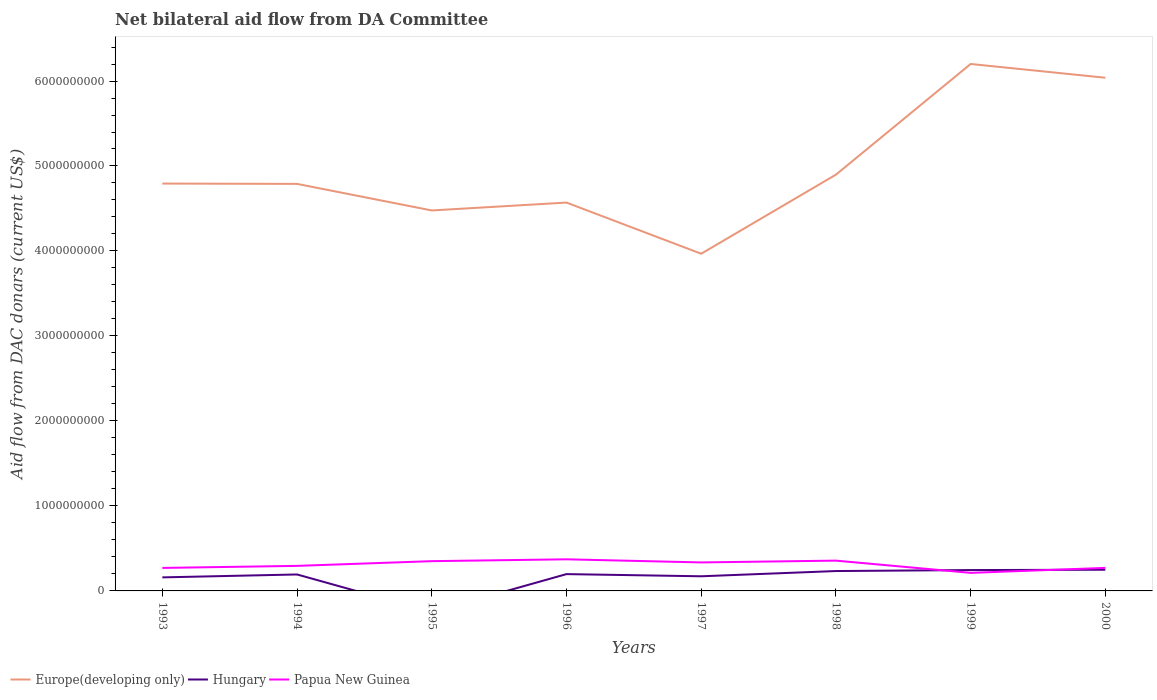How many different coloured lines are there?
Offer a very short reply. 3. Does the line corresponding to Europe(developing only) intersect with the line corresponding to Papua New Guinea?
Your answer should be very brief. No. Across all years, what is the maximum aid flow in in Papua New Guinea?
Give a very brief answer. 2.12e+08. What is the total aid flow in in Papua New Guinea in the graph?
Your answer should be compact. 1.23e+08. What is the difference between the highest and the second highest aid flow in in Hungary?
Your answer should be very brief. 2.49e+08. What is the difference between two consecutive major ticks on the Y-axis?
Give a very brief answer. 1.00e+09. Does the graph contain grids?
Give a very brief answer. No. Where does the legend appear in the graph?
Keep it short and to the point. Bottom left. How many legend labels are there?
Offer a terse response. 3. What is the title of the graph?
Ensure brevity in your answer.  Net bilateral aid flow from DA Committee. Does "Uzbekistan" appear as one of the legend labels in the graph?
Provide a short and direct response. No. What is the label or title of the X-axis?
Keep it short and to the point. Years. What is the label or title of the Y-axis?
Offer a very short reply. Aid flow from DAC donars (current US$). What is the Aid flow from DAC donars (current US$) of Europe(developing only) in 1993?
Ensure brevity in your answer.  4.79e+09. What is the Aid flow from DAC donars (current US$) in Hungary in 1993?
Make the answer very short. 1.59e+08. What is the Aid flow from DAC donars (current US$) in Papua New Guinea in 1993?
Your answer should be compact. 2.71e+08. What is the Aid flow from DAC donars (current US$) in Europe(developing only) in 1994?
Offer a terse response. 4.79e+09. What is the Aid flow from DAC donars (current US$) in Hungary in 1994?
Ensure brevity in your answer.  1.94e+08. What is the Aid flow from DAC donars (current US$) in Papua New Guinea in 1994?
Your answer should be very brief. 2.95e+08. What is the Aid flow from DAC donars (current US$) in Europe(developing only) in 1995?
Ensure brevity in your answer.  4.48e+09. What is the Aid flow from DAC donars (current US$) of Hungary in 1995?
Give a very brief answer. 0. What is the Aid flow from DAC donars (current US$) in Papua New Guinea in 1995?
Your answer should be compact. 3.50e+08. What is the Aid flow from DAC donars (current US$) in Europe(developing only) in 1996?
Your answer should be compact. 4.57e+09. What is the Aid flow from DAC donars (current US$) of Hungary in 1996?
Your answer should be very brief. 1.98e+08. What is the Aid flow from DAC donars (current US$) in Papua New Guinea in 1996?
Make the answer very short. 3.72e+08. What is the Aid flow from DAC donars (current US$) in Europe(developing only) in 1997?
Your answer should be very brief. 3.97e+09. What is the Aid flow from DAC donars (current US$) in Hungary in 1997?
Offer a very short reply. 1.72e+08. What is the Aid flow from DAC donars (current US$) of Papua New Guinea in 1997?
Keep it short and to the point. 3.35e+08. What is the Aid flow from DAC donars (current US$) in Europe(developing only) in 1998?
Your answer should be very brief. 4.90e+09. What is the Aid flow from DAC donars (current US$) in Hungary in 1998?
Provide a short and direct response. 2.34e+08. What is the Aid flow from DAC donars (current US$) in Papua New Guinea in 1998?
Your response must be concise. 3.56e+08. What is the Aid flow from DAC donars (current US$) in Europe(developing only) in 1999?
Offer a terse response. 6.20e+09. What is the Aid flow from DAC donars (current US$) of Hungary in 1999?
Your answer should be very brief. 2.45e+08. What is the Aid flow from DAC donars (current US$) of Papua New Guinea in 1999?
Your response must be concise. 2.12e+08. What is the Aid flow from DAC donars (current US$) of Europe(developing only) in 2000?
Your answer should be very brief. 6.04e+09. What is the Aid flow from DAC donars (current US$) in Hungary in 2000?
Give a very brief answer. 2.49e+08. What is the Aid flow from DAC donars (current US$) in Papua New Guinea in 2000?
Make the answer very short. 2.71e+08. Across all years, what is the maximum Aid flow from DAC donars (current US$) in Europe(developing only)?
Offer a very short reply. 6.20e+09. Across all years, what is the maximum Aid flow from DAC donars (current US$) in Hungary?
Your response must be concise. 2.49e+08. Across all years, what is the maximum Aid flow from DAC donars (current US$) in Papua New Guinea?
Offer a terse response. 3.72e+08. Across all years, what is the minimum Aid flow from DAC donars (current US$) in Europe(developing only)?
Ensure brevity in your answer.  3.97e+09. Across all years, what is the minimum Aid flow from DAC donars (current US$) of Papua New Guinea?
Offer a very short reply. 2.12e+08. What is the total Aid flow from DAC donars (current US$) of Europe(developing only) in the graph?
Provide a succinct answer. 3.97e+1. What is the total Aid flow from DAC donars (current US$) of Hungary in the graph?
Ensure brevity in your answer.  1.45e+09. What is the total Aid flow from DAC donars (current US$) in Papua New Guinea in the graph?
Offer a very short reply. 2.46e+09. What is the difference between the Aid flow from DAC donars (current US$) of Europe(developing only) in 1993 and that in 1994?
Your answer should be compact. 3.82e+06. What is the difference between the Aid flow from DAC donars (current US$) in Hungary in 1993 and that in 1994?
Keep it short and to the point. -3.43e+07. What is the difference between the Aid flow from DAC donars (current US$) in Papua New Guinea in 1993 and that in 1994?
Your response must be concise. -2.41e+07. What is the difference between the Aid flow from DAC donars (current US$) in Europe(developing only) in 1993 and that in 1995?
Ensure brevity in your answer.  3.16e+08. What is the difference between the Aid flow from DAC donars (current US$) of Papua New Guinea in 1993 and that in 1995?
Your response must be concise. -7.95e+07. What is the difference between the Aid flow from DAC donars (current US$) in Europe(developing only) in 1993 and that in 1996?
Provide a short and direct response. 2.24e+08. What is the difference between the Aid flow from DAC donars (current US$) in Hungary in 1993 and that in 1996?
Offer a terse response. -3.85e+07. What is the difference between the Aid flow from DAC donars (current US$) of Papua New Guinea in 1993 and that in 1996?
Keep it short and to the point. -1.01e+08. What is the difference between the Aid flow from DAC donars (current US$) of Europe(developing only) in 1993 and that in 1997?
Give a very brief answer. 8.26e+08. What is the difference between the Aid flow from DAC donars (current US$) in Hungary in 1993 and that in 1997?
Offer a very short reply. -1.29e+07. What is the difference between the Aid flow from DAC donars (current US$) in Papua New Guinea in 1993 and that in 1997?
Ensure brevity in your answer.  -6.48e+07. What is the difference between the Aid flow from DAC donars (current US$) in Europe(developing only) in 1993 and that in 1998?
Your answer should be compact. -1.05e+08. What is the difference between the Aid flow from DAC donars (current US$) in Hungary in 1993 and that in 1998?
Your response must be concise. -7.45e+07. What is the difference between the Aid flow from DAC donars (current US$) of Papua New Guinea in 1993 and that in 1998?
Offer a terse response. -8.58e+07. What is the difference between the Aid flow from DAC donars (current US$) in Europe(developing only) in 1993 and that in 1999?
Your answer should be compact. -1.41e+09. What is the difference between the Aid flow from DAC donars (current US$) of Hungary in 1993 and that in 1999?
Provide a short and direct response. -8.61e+07. What is the difference between the Aid flow from DAC donars (current US$) in Papua New Guinea in 1993 and that in 1999?
Your answer should be compact. 5.82e+07. What is the difference between the Aid flow from DAC donars (current US$) of Europe(developing only) in 1993 and that in 2000?
Offer a very short reply. -1.25e+09. What is the difference between the Aid flow from DAC donars (current US$) in Hungary in 1993 and that in 2000?
Provide a short and direct response. -8.99e+07. What is the difference between the Aid flow from DAC donars (current US$) of Papua New Guinea in 1993 and that in 2000?
Your answer should be compact. -2.60e+05. What is the difference between the Aid flow from DAC donars (current US$) of Europe(developing only) in 1994 and that in 1995?
Your answer should be very brief. 3.13e+08. What is the difference between the Aid flow from DAC donars (current US$) of Papua New Guinea in 1994 and that in 1995?
Give a very brief answer. -5.54e+07. What is the difference between the Aid flow from DAC donars (current US$) in Europe(developing only) in 1994 and that in 1996?
Provide a succinct answer. 2.20e+08. What is the difference between the Aid flow from DAC donars (current US$) of Hungary in 1994 and that in 1996?
Your answer should be compact. -4.16e+06. What is the difference between the Aid flow from DAC donars (current US$) in Papua New Guinea in 1994 and that in 1996?
Your answer should be compact. -7.72e+07. What is the difference between the Aid flow from DAC donars (current US$) of Europe(developing only) in 1994 and that in 1997?
Your answer should be very brief. 8.22e+08. What is the difference between the Aid flow from DAC donars (current US$) of Hungary in 1994 and that in 1997?
Give a very brief answer. 2.14e+07. What is the difference between the Aid flow from DAC donars (current US$) in Papua New Guinea in 1994 and that in 1997?
Ensure brevity in your answer.  -4.06e+07. What is the difference between the Aid flow from DAC donars (current US$) of Europe(developing only) in 1994 and that in 1998?
Ensure brevity in your answer.  -1.09e+08. What is the difference between the Aid flow from DAC donars (current US$) in Hungary in 1994 and that in 1998?
Offer a terse response. -4.02e+07. What is the difference between the Aid flow from DAC donars (current US$) of Papua New Guinea in 1994 and that in 1998?
Offer a very short reply. -6.17e+07. What is the difference between the Aid flow from DAC donars (current US$) in Europe(developing only) in 1994 and that in 1999?
Keep it short and to the point. -1.41e+09. What is the difference between the Aid flow from DAC donars (current US$) in Hungary in 1994 and that in 1999?
Your answer should be very brief. -5.18e+07. What is the difference between the Aid flow from DAC donars (current US$) in Papua New Guinea in 1994 and that in 1999?
Provide a succinct answer. 8.23e+07. What is the difference between the Aid flow from DAC donars (current US$) of Europe(developing only) in 1994 and that in 2000?
Make the answer very short. -1.25e+09. What is the difference between the Aid flow from DAC donars (current US$) of Hungary in 1994 and that in 2000?
Give a very brief answer. -5.56e+07. What is the difference between the Aid flow from DAC donars (current US$) of Papua New Guinea in 1994 and that in 2000?
Ensure brevity in your answer.  2.38e+07. What is the difference between the Aid flow from DAC donars (current US$) in Europe(developing only) in 1995 and that in 1996?
Keep it short and to the point. -9.28e+07. What is the difference between the Aid flow from DAC donars (current US$) of Papua New Guinea in 1995 and that in 1996?
Provide a short and direct response. -2.17e+07. What is the difference between the Aid flow from DAC donars (current US$) in Europe(developing only) in 1995 and that in 1997?
Your answer should be very brief. 5.09e+08. What is the difference between the Aid flow from DAC donars (current US$) of Papua New Guinea in 1995 and that in 1997?
Your response must be concise. 1.48e+07. What is the difference between the Aid flow from DAC donars (current US$) in Europe(developing only) in 1995 and that in 1998?
Give a very brief answer. -4.21e+08. What is the difference between the Aid flow from DAC donars (current US$) of Papua New Guinea in 1995 and that in 1998?
Make the answer very short. -6.30e+06. What is the difference between the Aid flow from DAC donars (current US$) of Europe(developing only) in 1995 and that in 1999?
Give a very brief answer. -1.72e+09. What is the difference between the Aid flow from DAC donars (current US$) in Papua New Guinea in 1995 and that in 1999?
Provide a short and direct response. 1.38e+08. What is the difference between the Aid flow from DAC donars (current US$) of Europe(developing only) in 1995 and that in 2000?
Keep it short and to the point. -1.56e+09. What is the difference between the Aid flow from DAC donars (current US$) of Papua New Guinea in 1995 and that in 2000?
Your answer should be compact. 7.92e+07. What is the difference between the Aid flow from DAC donars (current US$) in Europe(developing only) in 1996 and that in 1997?
Provide a short and direct response. 6.02e+08. What is the difference between the Aid flow from DAC donars (current US$) of Hungary in 1996 and that in 1997?
Keep it short and to the point. 2.56e+07. What is the difference between the Aid flow from DAC donars (current US$) in Papua New Guinea in 1996 and that in 1997?
Offer a terse response. 3.65e+07. What is the difference between the Aid flow from DAC donars (current US$) of Europe(developing only) in 1996 and that in 1998?
Offer a terse response. -3.28e+08. What is the difference between the Aid flow from DAC donars (current US$) of Hungary in 1996 and that in 1998?
Your answer should be compact. -3.61e+07. What is the difference between the Aid flow from DAC donars (current US$) of Papua New Guinea in 1996 and that in 1998?
Give a very brief answer. 1.54e+07. What is the difference between the Aid flow from DAC donars (current US$) of Europe(developing only) in 1996 and that in 1999?
Offer a terse response. -1.63e+09. What is the difference between the Aid flow from DAC donars (current US$) in Hungary in 1996 and that in 1999?
Offer a very short reply. -4.77e+07. What is the difference between the Aid flow from DAC donars (current US$) of Papua New Guinea in 1996 and that in 1999?
Give a very brief answer. 1.59e+08. What is the difference between the Aid flow from DAC donars (current US$) of Europe(developing only) in 1996 and that in 2000?
Your response must be concise. -1.47e+09. What is the difference between the Aid flow from DAC donars (current US$) of Hungary in 1996 and that in 2000?
Provide a short and direct response. -5.14e+07. What is the difference between the Aid flow from DAC donars (current US$) of Papua New Guinea in 1996 and that in 2000?
Your answer should be very brief. 1.01e+08. What is the difference between the Aid flow from DAC donars (current US$) of Europe(developing only) in 1997 and that in 1998?
Your answer should be very brief. -9.30e+08. What is the difference between the Aid flow from DAC donars (current US$) of Hungary in 1997 and that in 1998?
Make the answer very short. -6.17e+07. What is the difference between the Aid flow from DAC donars (current US$) of Papua New Guinea in 1997 and that in 1998?
Ensure brevity in your answer.  -2.11e+07. What is the difference between the Aid flow from DAC donars (current US$) of Europe(developing only) in 1997 and that in 1999?
Make the answer very short. -2.23e+09. What is the difference between the Aid flow from DAC donars (current US$) in Hungary in 1997 and that in 1999?
Make the answer very short. -7.33e+07. What is the difference between the Aid flow from DAC donars (current US$) in Papua New Guinea in 1997 and that in 1999?
Give a very brief answer. 1.23e+08. What is the difference between the Aid flow from DAC donars (current US$) of Europe(developing only) in 1997 and that in 2000?
Ensure brevity in your answer.  -2.07e+09. What is the difference between the Aid flow from DAC donars (current US$) of Hungary in 1997 and that in 2000?
Your answer should be compact. -7.70e+07. What is the difference between the Aid flow from DAC donars (current US$) in Papua New Guinea in 1997 and that in 2000?
Make the answer very short. 6.45e+07. What is the difference between the Aid flow from DAC donars (current US$) of Europe(developing only) in 1998 and that in 1999?
Your answer should be compact. -1.30e+09. What is the difference between the Aid flow from DAC donars (current US$) in Hungary in 1998 and that in 1999?
Offer a very short reply. -1.16e+07. What is the difference between the Aid flow from DAC donars (current US$) in Papua New Guinea in 1998 and that in 1999?
Provide a short and direct response. 1.44e+08. What is the difference between the Aid flow from DAC donars (current US$) in Europe(developing only) in 1998 and that in 2000?
Keep it short and to the point. -1.14e+09. What is the difference between the Aid flow from DAC donars (current US$) in Hungary in 1998 and that in 2000?
Offer a very short reply. -1.54e+07. What is the difference between the Aid flow from DAC donars (current US$) of Papua New Guinea in 1998 and that in 2000?
Provide a succinct answer. 8.56e+07. What is the difference between the Aid flow from DAC donars (current US$) of Europe(developing only) in 1999 and that in 2000?
Provide a succinct answer. 1.62e+08. What is the difference between the Aid flow from DAC donars (current US$) of Hungary in 1999 and that in 2000?
Your answer should be compact. -3.76e+06. What is the difference between the Aid flow from DAC donars (current US$) in Papua New Guinea in 1999 and that in 2000?
Give a very brief answer. -5.84e+07. What is the difference between the Aid flow from DAC donars (current US$) in Europe(developing only) in 1993 and the Aid flow from DAC donars (current US$) in Hungary in 1994?
Your answer should be very brief. 4.60e+09. What is the difference between the Aid flow from DAC donars (current US$) of Europe(developing only) in 1993 and the Aid flow from DAC donars (current US$) of Papua New Guinea in 1994?
Offer a very short reply. 4.50e+09. What is the difference between the Aid flow from DAC donars (current US$) of Hungary in 1993 and the Aid flow from DAC donars (current US$) of Papua New Guinea in 1994?
Provide a short and direct response. -1.35e+08. What is the difference between the Aid flow from DAC donars (current US$) in Europe(developing only) in 1993 and the Aid flow from DAC donars (current US$) in Papua New Guinea in 1995?
Your answer should be compact. 4.44e+09. What is the difference between the Aid flow from DAC donars (current US$) of Hungary in 1993 and the Aid flow from DAC donars (current US$) of Papua New Guinea in 1995?
Your answer should be compact. -1.91e+08. What is the difference between the Aid flow from DAC donars (current US$) of Europe(developing only) in 1993 and the Aid flow from DAC donars (current US$) of Hungary in 1996?
Give a very brief answer. 4.60e+09. What is the difference between the Aid flow from DAC donars (current US$) in Europe(developing only) in 1993 and the Aid flow from DAC donars (current US$) in Papua New Guinea in 1996?
Your response must be concise. 4.42e+09. What is the difference between the Aid flow from DAC donars (current US$) of Hungary in 1993 and the Aid flow from DAC donars (current US$) of Papua New Guinea in 1996?
Ensure brevity in your answer.  -2.13e+08. What is the difference between the Aid flow from DAC donars (current US$) of Europe(developing only) in 1993 and the Aid flow from DAC donars (current US$) of Hungary in 1997?
Your answer should be compact. 4.62e+09. What is the difference between the Aid flow from DAC donars (current US$) of Europe(developing only) in 1993 and the Aid flow from DAC donars (current US$) of Papua New Guinea in 1997?
Give a very brief answer. 4.46e+09. What is the difference between the Aid flow from DAC donars (current US$) in Hungary in 1993 and the Aid flow from DAC donars (current US$) in Papua New Guinea in 1997?
Your answer should be compact. -1.76e+08. What is the difference between the Aid flow from DAC donars (current US$) in Europe(developing only) in 1993 and the Aid flow from DAC donars (current US$) in Hungary in 1998?
Make the answer very short. 4.56e+09. What is the difference between the Aid flow from DAC donars (current US$) in Europe(developing only) in 1993 and the Aid flow from DAC donars (current US$) in Papua New Guinea in 1998?
Provide a succinct answer. 4.44e+09. What is the difference between the Aid flow from DAC donars (current US$) in Hungary in 1993 and the Aid flow from DAC donars (current US$) in Papua New Guinea in 1998?
Offer a very short reply. -1.97e+08. What is the difference between the Aid flow from DAC donars (current US$) of Europe(developing only) in 1993 and the Aid flow from DAC donars (current US$) of Hungary in 1999?
Your answer should be very brief. 4.55e+09. What is the difference between the Aid flow from DAC donars (current US$) of Europe(developing only) in 1993 and the Aid flow from DAC donars (current US$) of Papua New Guinea in 1999?
Give a very brief answer. 4.58e+09. What is the difference between the Aid flow from DAC donars (current US$) in Hungary in 1993 and the Aid flow from DAC donars (current US$) in Papua New Guinea in 1999?
Offer a terse response. -5.31e+07. What is the difference between the Aid flow from DAC donars (current US$) in Europe(developing only) in 1993 and the Aid flow from DAC donars (current US$) in Hungary in 2000?
Keep it short and to the point. 4.54e+09. What is the difference between the Aid flow from DAC donars (current US$) in Europe(developing only) in 1993 and the Aid flow from DAC donars (current US$) in Papua New Guinea in 2000?
Your answer should be very brief. 4.52e+09. What is the difference between the Aid flow from DAC donars (current US$) in Hungary in 1993 and the Aid flow from DAC donars (current US$) in Papua New Guinea in 2000?
Give a very brief answer. -1.12e+08. What is the difference between the Aid flow from DAC donars (current US$) of Europe(developing only) in 1994 and the Aid flow from DAC donars (current US$) of Papua New Guinea in 1995?
Ensure brevity in your answer.  4.44e+09. What is the difference between the Aid flow from DAC donars (current US$) in Hungary in 1994 and the Aid flow from DAC donars (current US$) in Papua New Guinea in 1995?
Offer a very short reply. -1.57e+08. What is the difference between the Aid flow from DAC donars (current US$) of Europe(developing only) in 1994 and the Aid flow from DAC donars (current US$) of Hungary in 1996?
Your response must be concise. 4.59e+09. What is the difference between the Aid flow from DAC donars (current US$) of Europe(developing only) in 1994 and the Aid flow from DAC donars (current US$) of Papua New Guinea in 1996?
Make the answer very short. 4.42e+09. What is the difference between the Aid flow from DAC donars (current US$) in Hungary in 1994 and the Aid flow from DAC donars (current US$) in Papua New Guinea in 1996?
Your answer should be compact. -1.78e+08. What is the difference between the Aid flow from DAC donars (current US$) of Europe(developing only) in 1994 and the Aid flow from DAC donars (current US$) of Hungary in 1997?
Ensure brevity in your answer.  4.62e+09. What is the difference between the Aid flow from DAC donars (current US$) in Europe(developing only) in 1994 and the Aid flow from DAC donars (current US$) in Papua New Guinea in 1997?
Your answer should be very brief. 4.45e+09. What is the difference between the Aid flow from DAC donars (current US$) of Hungary in 1994 and the Aid flow from DAC donars (current US$) of Papua New Guinea in 1997?
Offer a very short reply. -1.42e+08. What is the difference between the Aid flow from DAC donars (current US$) of Europe(developing only) in 1994 and the Aid flow from DAC donars (current US$) of Hungary in 1998?
Offer a very short reply. 4.56e+09. What is the difference between the Aid flow from DAC donars (current US$) of Europe(developing only) in 1994 and the Aid flow from DAC donars (current US$) of Papua New Guinea in 1998?
Ensure brevity in your answer.  4.43e+09. What is the difference between the Aid flow from DAC donars (current US$) of Hungary in 1994 and the Aid flow from DAC donars (current US$) of Papua New Guinea in 1998?
Give a very brief answer. -1.63e+08. What is the difference between the Aid flow from DAC donars (current US$) of Europe(developing only) in 1994 and the Aid flow from DAC donars (current US$) of Hungary in 1999?
Your answer should be very brief. 4.54e+09. What is the difference between the Aid flow from DAC donars (current US$) of Europe(developing only) in 1994 and the Aid flow from DAC donars (current US$) of Papua New Guinea in 1999?
Make the answer very short. 4.58e+09. What is the difference between the Aid flow from DAC donars (current US$) in Hungary in 1994 and the Aid flow from DAC donars (current US$) in Papua New Guinea in 1999?
Provide a succinct answer. -1.88e+07. What is the difference between the Aid flow from DAC donars (current US$) of Europe(developing only) in 1994 and the Aid flow from DAC donars (current US$) of Hungary in 2000?
Give a very brief answer. 4.54e+09. What is the difference between the Aid flow from DAC donars (current US$) of Europe(developing only) in 1994 and the Aid flow from DAC donars (current US$) of Papua New Guinea in 2000?
Your response must be concise. 4.52e+09. What is the difference between the Aid flow from DAC donars (current US$) in Hungary in 1994 and the Aid flow from DAC donars (current US$) in Papua New Guinea in 2000?
Provide a short and direct response. -7.73e+07. What is the difference between the Aid flow from DAC donars (current US$) in Europe(developing only) in 1995 and the Aid flow from DAC donars (current US$) in Hungary in 1996?
Offer a very short reply. 4.28e+09. What is the difference between the Aid flow from DAC donars (current US$) of Europe(developing only) in 1995 and the Aid flow from DAC donars (current US$) of Papua New Guinea in 1996?
Your answer should be compact. 4.10e+09. What is the difference between the Aid flow from DAC donars (current US$) in Europe(developing only) in 1995 and the Aid flow from DAC donars (current US$) in Hungary in 1997?
Offer a terse response. 4.30e+09. What is the difference between the Aid flow from DAC donars (current US$) in Europe(developing only) in 1995 and the Aid flow from DAC donars (current US$) in Papua New Guinea in 1997?
Ensure brevity in your answer.  4.14e+09. What is the difference between the Aid flow from DAC donars (current US$) of Europe(developing only) in 1995 and the Aid flow from DAC donars (current US$) of Hungary in 1998?
Offer a very short reply. 4.24e+09. What is the difference between the Aid flow from DAC donars (current US$) of Europe(developing only) in 1995 and the Aid flow from DAC donars (current US$) of Papua New Guinea in 1998?
Keep it short and to the point. 4.12e+09. What is the difference between the Aid flow from DAC donars (current US$) of Europe(developing only) in 1995 and the Aid flow from DAC donars (current US$) of Hungary in 1999?
Your answer should be compact. 4.23e+09. What is the difference between the Aid flow from DAC donars (current US$) of Europe(developing only) in 1995 and the Aid flow from DAC donars (current US$) of Papua New Guinea in 1999?
Offer a very short reply. 4.26e+09. What is the difference between the Aid flow from DAC donars (current US$) in Europe(developing only) in 1995 and the Aid flow from DAC donars (current US$) in Hungary in 2000?
Offer a terse response. 4.23e+09. What is the difference between the Aid flow from DAC donars (current US$) of Europe(developing only) in 1995 and the Aid flow from DAC donars (current US$) of Papua New Guinea in 2000?
Provide a short and direct response. 4.21e+09. What is the difference between the Aid flow from DAC donars (current US$) in Europe(developing only) in 1996 and the Aid flow from DAC donars (current US$) in Hungary in 1997?
Your response must be concise. 4.40e+09. What is the difference between the Aid flow from DAC donars (current US$) in Europe(developing only) in 1996 and the Aid flow from DAC donars (current US$) in Papua New Guinea in 1997?
Provide a succinct answer. 4.23e+09. What is the difference between the Aid flow from DAC donars (current US$) in Hungary in 1996 and the Aid flow from DAC donars (current US$) in Papua New Guinea in 1997?
Your response must be concise. -1.38e+08. What is the difference between the Aid flow from DAC donars (current US$) of Europe(developing only) in 1996 and the Aid flow from DAC donars (current US$) of Hungary in 1998?
Your answer should be compact. 4.34e+09. What is the difference between the Aid flow from DAC donars (current US$) of Europe(developing only) in 1996 and the Aid flow from DAC donars (current US$) of Papua New Guinea in 1998?
Ensure brevity in your answer.  4.21e+09. What is the difference between the Aid flow from DAC donars (current US$) in Hungary in 1996 and the Aid flow from DAC donars (current US$) in Papua New Guinea in 1998?
Provide a short and direct response. -1.59e+08. What is the difference between the Aid flow from DAC donars (current US$) in Europe(developing only) in 1996 and the Aid flow from DAC donars (current US$) in Hungary in 1999?
Your answer should be compact. 4.32e+09. What is the difference between the Aid flow from DAC donars (current US$) of Europe(developing only) in 1996 and the Aid flow from DAC donars (current US$) of Papua New Guinea in 1999?
Make the answer very short. 4.36e+09. What is the difference between the Aid flow from DAC donars (current US$) in Hungary in 1996 and the Aid flow from DAC donars (current US$) in Papua New Guinea in 1999?
Your answer should be very brief. -1.47e+07. What is the difference between the Aid flow from DAC donars (current US$) in Europe(developing only) in 1996 and the Aid flow from DAC donars (current US$) in Hungary in 2000?
Your response must be concise. 4.32e+09. What is the difference between the Aid flow from DAC donars (current US$) of Europe(developing only) in 1996 and the Aid flow from DAC donars (current US$) of Papua New Guinea in 2000?
Your answer should be very brief. 4.30e+09. What is the difference between the Aid flow from DAC donars (current US$) in Hungary in 1996 and the Aid flow from DAC donars (current US$) in Papua New Guinea in 2000?
Keep it short and to the point. -7.31e+07. What is the difference between the Aid flow from DAC donars (current US$) in Europe(developing only) in 1997 and the Aid flow from DAC donars (current US$) in Hungary in 1998?
Your answer should be very brief. 3.73e+09. What is the difference between the Aid flow from DAC donars (current US$) in Europe(developing only) in 1997 and the Aid flow from DAC donars (current US$) in Papua New Guinea in 1998?
Give a very brief answer. 3.61e+09. What is the difference between the Aid flow from DAC donars (current US$) in Hungary in 1997 and the Aid flow from DAC donars (current US$) in Papua New Guinea in 1998?
Ensure brevity in your answer.  -1.84e+08. What is the difference between the Aid flow from DAC donars (current US$) of Europe(developing only) in 1997 and the Aid flow from DAC donars (current US$) of Hungary in 1999?
Your answer should be compact. 3.72e+09. What is the difference between the Aid flow from DAC donars (current US$) of Europe(developing only) in 1997 and the Aid flow from DAC donars (current US$) of Papua New Guinea in 1999?
Provide a succinct answer. 3.76e+09. What is the difference between the Aid flow from DAC donars (current US$) in Hungary in 1997 and the Aid flow from DAC donars (current US$) in Papua New Guinea in 1999?
Your response must be concise. -4.03e+07. What is the difference between the Aid flow from DAC donars (current US$) of Europe(developing only) in 1997 and the Aid flow from DAC donars (current US$) of Hungary in 2000?
Give a very brief answer. 3.72e+09. What is the difference between the Aid flow from DAC donars (current US$) in Europe(developing only) in 1997 and the Aid flow from DAC donars (current US$) in Papua New Guinea in 2000?
Keep it short and to the point. 3.70e+09. What is the difference between the Aid flow from DAC donars (current US$) in Hungary in 1997 and the Aid flow from DAC donars (current US$) in Papua New Guinea in 2000?
Your answer should be compact. -9.87e+07. What is the difference between the Aid flow from DAC donars (current US$) in Europe(developing only) in 1998 and the Aid flow from DAC donars (current US$) in Hungary in 1999?
Offer a terse response. 4.65e+09. What is the difference between the Aid flow from DAC donars (current US$) of Europe(developing only) in 1998 and the Aid flow from DAC donars (current US$) of Papua New Guinea in 1999?
Your answer should be compact. 4.69e+09. What is the difference between the Aid flow from DAC donars (current US$) of Hungary in 1998 and the Aid flow from DAC donars (current US$) of Papua New Guinea in 1999?
Provide a succinct answer. 2.14e+07. What is the difference between the Aid flow from DAC donars (current US$) in Europe(developing only) in 1998 and the Aid flow from DAC donars (current US$) in Hungary in 2000?
Offer a terse response. 4.65e+09. What is the difference between the Aid flow from DAC donars (current US$) of Europe(developing only) in 1998 and the Aid flow from DAC donars (current US$) of Papua New Guinea in 2000?
Provide a short and direct response. 4.63e+09. What is the difference between the Aid flow from DAC donars (current US$) of Hungary in 1998 and the Aid flow from DAC donars (current US$) of Papua New Guinea in 2000?
Your answer should be very brief. -3.70e+07. What is the difference between the Aid flow from DAC donars (current US$) in Europe(developing only) in 1999 and the Aid flow from DAC donars (current US$) in Hungary in 2000?
Provide a short and direct response. 5.95e+09. What is the difference between the Aid flow from DAC donars (current US$) of Europe(developing only) in 1999 and the Aid flow from DAC donars (current US$) of Papua New Guinea in 2000?
Offer a terse response. 5.93e+09. What is the difference between the Aid flow from DAC donars (current US$) in Hungary in 1999 and the Aid flow from DAC donars (current US$) in Papua New Guinea in 2000?
Give a very brief answer. -2.54e+07. What is the average Aid flow from DAC donars (current US$) in Europe(developing only) per year?
Offer a terse response. 4.97e+09. What is the average Aid flow from DAC donars (current US$) in Hungary per year?
Your answer should be compact. 1.81e+08. What is the average Aid flow from DAC donars (current US$) of Papua New Guinea per year?
Provide a short and direct response. 3.08e+08. In the year 1993, what is the difference between the Aid flow from DAC donars (current US$) of Europe(developing only) and Aid flow from DAC donars (current US$) of Hungary?
Offer a terse response. 4.63e+09. In the year 1993, what is the difference between the Aid flow from DAC donars (current US$) in Europe(developing only) and Aid flow from DAC donars (current US$) in Papua New Guinea?
Offer a very short reply. 4.52e+09. In the year 1993, what is the difference between the Aid flow from DAC donars (current US$) in Hungary and Aid flow from DAC donars (current US$) in Papua New Guinea?
Ensure brevity in your answer.  -1.11e+08. In the year 1994, what is the difference between the Aid flow from DAC donars (current US$) in Europe(developing only) and Aid flow from DAC donars (current US$) in Hungary?
Your response must be concise. 4.60e+09. In the year 1994, what is the difference between the Aid flow from DAC donars (current US$) of Europe(developing only) and Aid flow from DAC donars (current US$) of Papua New Guinea?
Your answer should be compact. 4.49e+09. In the year 1994, what is the difference between the Aid flow from DAC donars (current US$) of Hungary and Aid flow from DAC donars (current US$) of Papua New Guinea?
Make the answer very short. -1.01e+08. In the year 1995, what is the difference between the Aid flow from DAC donars (current US$) in Europe(developing only) and Aid flow from DAC donars (current US$) in Papua New Guinea?
Offer a terse response. 4.13e+09. In the year 1996, what is the difference between the Aid flow from DAC donars (current US$) of Europe(developing only) and Aid flow from DAC donars (current US$) of Hungary?
Your answer should be very brief. 4.37e+09. In the year 1996, what is the difference between the Aid flow from DAC donars (current US$) in Europe(developing only) and Aid flow from DAC donars (current US$) in Papua New Guinea?
Offer a terse response. 4.20e+09. In the year 1996, what is the difference between the Aid flow from DAC donars (current US$) of Hungary and Aid flow from DAC donars (current US$) of Papua New Guinea?
Provide a succinct answer. -1.74e+08. In the year 1997, what is the difference between the Aid flow from DAC donars (current US$) in Europe(developing only) and Aid flow from DAC donars (current US$) in Hungary?
Keep it short and to the point. 3.80e+09. In the year 1997, what is the difference between the Aid flow from DAC donars (current US$) in Europe(developing only) and Aid flow from DAC donars (current US$) in Papua New Guinea?
Provide a short and direct response. 3.63e+09. In the year 1997, what is the difference between the Aid flow from DAC donars (current US$) in Hungary and Aid flow from DAC donars (current US$) in Papua New Guinea?
Offer a terse response. -1.63e+08. In the year 1998, what is the difference between the Aid flow from DAC donars (current US$) in Europe(developing only) and Aid flow from DAC donars (current US$) in Hungary?
Your answer should be very brief. 4.66e+09. In the year 1998, what is the difference between the Aid flow from DAC donars (current US$) of Europe(developing only) and Aid flow from DAC donars (current US$) of Papua New Guinea?
Provide a succinct answer. 4.54e+09. In the year 1998, what is the difference between the Aid flow from DAC donars (current US$) of Hungary and Aid flow from DAC donars (current US$) of Papua New Guinea?
Your answer should be very brief. -1.23e+08. In the year 1999, what is the difference between the Aid flow from DAC donars (current US$) of Europe(developing only) and Aid flow from DAC donars (current US$) of Hungary?
Keep it short and to the point. 5.95e+09. In the year 1999, what is the difference between the Aid flow from DAC donars (current US$) in Europe(developing only) and Aid flow from DAC donars (current US$) in Papua New Guinea?
Offer a terse response. 5.99e+09. In the year 1999, what is the difference between the Aid flow from DAC donars (current US$) in Hungary and Aid flow from DAC donars (current US$) in Papua New Guinea?
Give a very brief answer. 3.30e+07. In the year 2000, what is the difference between the Aid flow from DAC donars (current US$) in Europe(developing only) and Aid flow from DAC donars (current US$) in Hungary?
Your response must be concise. 5.79e+09. In the year 2000, what is the difference between the Aid flow from DAC donars (current US$) of Europe(developing only) and Aid flow from DAC donars (current US$) of Papua New Guinea?
Offer a terse response. 5.77e+09. In the year 2000, what is the difference between the Aid flow from DAC donars (current US$) in Hungary and Aid flow from DAC donars (current US$) in Papua New Guinea?
Ensure brevity in your answer.  -2.17e+07. What is the ratio of the Aid flow from DAC donars (current US$) of Europe(developing only) in 1993 to that in 1994?
Offer a terse response. 1. What is the ratio of the Aid flow from DAC donars (current US$) in Hungary in 1993 to that in 1994?
Keep it short and to the point. 0.82. What is the ratio of the Aid flow from DAC donars (current US$) in Papua New Guinea in 1993 to that in 1994?
Provide a short and direct response. 0.92. What is the ratio of the Aid flow from DAC donars (current US$) of Europe(developing only) in 1993 to that in 1995?
Offer a very short reply. 1.07. What is the ratio of the Aid flow from DAC donars (current US$) of Papua New Guinea in 1993 to that in 1995?
Offer a terse response. 0.77. What is the ratio of the Aid flow from DAC donars (current US$) of Europe(developing only) in 1993 to that in 1996?
Ensure brevity in your answer.  1.05. What is the ratio of the Aid flow from DAC donars (current US$) of Hungary in 1993 to that in 1996?
Ensure brevity in your answer.  0.81. What is the ratio of the Aid flow from DAC donars (current US$) in Papua New Guinea in 1993 to that in 1996?
Offer a very short reply. 0.73. What is the ratio of the Aid flow from DAC donars (current US$) in Europe(developing only) in 1993 to that in 1997?
Give a very brief answer. 1.21. What is the ratio of the Aid flow from DAC donars (current US$) in Hungary in 1993 to that in 1997?
Your answer should be compact. 0.93. What is the ratio of the Aid flow from DAC donars (current US$) in Papua New Guinea in 1993 to that in 1997?
Give a very brief answer. 0.81. What is the ratio of the Aid flow from DAC donars (current US$) in Europe(developing only) in 1993 to that in 1998?
Provide a short and direct response. 0.98. What is the ratio of the Aid flow from DAC donars (current US$) of Hungary in 1993 to that in 1998?
Your answer should be compact. 0.68. What is the ratio of the Aid flow from DAC donars (current US$) of Papua New Guinea in 1993 to that in 1998?
Keep it short and to the point. 0.76. What is the ratio of the Aid flow from DAC donars (current US$) in Europe(developing only) in 1993 to that in 1999?
Make the answer very short. 0.77. What is the ratio of the Aid flow from DAC donars (current US$) in Hungary in 1993 to that in 1999?
Offer a very short reply. 0.65. What is the ratio of the Aid flow from DAC donars (current US$) of Papua New Guinea in 1993 to that in 1999?
Offer a terse response. 1.27. What is the ratio of the Aid flow from DAC donars (current US$) of Europe(developing only) in 1993 to that in 2000?
Ensure brevity in your answer.  0.79. What is the ratio of the Aid flow from DAC donars (current US$) in Hungary in 1993 to that in 2000?
Offer a terse response. 0.64. What is the ratio of the Aid flow from DAC donars (current US$) of Papua New Guinea in 1993 to that in 2000?
Make the answer very short. 1. What is the ratio of the Aid flow from DAC donars (current US$) in Europe(developing only) in 1994 to that in 1995?
Your answer should be very brief. 1.07. What is the ratio of the Aid flow from DAC donars (current US$) in Papua New Guinea in 1994 to that in 1995?
Make the answer very short. 0.84. What is the ratio of the Aid flow from DAC donars (current US$) of Europe(developing only) in 1994 to that in 1996?
Keep it short and to the point. 1.05. What is the ratio of the Aid flow from DAC donars (current US$) of Hungary in 1994 to that in 1996?
Your answer should be very brief. 0.98. What is the ratio of the Aid flow from DAC donars (current US$) in Papua New Guinea in 1994 to that in 1996?
Ensure brevity in your answer.  0.79. What is the ratio of the Aid flow from DAC donars (current US$) of Europe(developing only) in 1994 to that in 1997?
Provide a short and direct response. 1.21. What is the ratio of the Aid flow from DAC donars (current US$) in Hungary in 1994 to that in 1997?
Offer a very short reply. 1.12. What is the ratio of the Aid flow from DAC donars (current US$) of Papua New Guinea in 1994 to that in 1997?
Give a very brief answer. 0.88. What is the ratio of the Aid flow from DAC donars (current US$) in Europe(developing only) in 1994 to that in 1998?
Offer a very short reply. 0.98. What is the ratio of the Aid flow from DAC donars (current US$) in Hungary in 1994 to that in 1998?
Make the answer very short. 0.83. What is the ratio of the Aid flow from DAC donars (current US$) of Papua New Guinea in 1994 to that in 1998?
Give a very brief answer. 0.83. What is the ratio of the Aid flow from DAC donars (current US$) of Europe(developing only) in 1994 to that in 1999?
Provide a succinct answer. 0.77. What is the ratio of the Aid flow from DAC donars (current US$) of Hungary in 1994 to that in 1999?
Offer a very short reply. 0.79. What is the ratio of the Aid flow from DAC donars (current US$) in Papua New Guinea in 1994 to that in 1999?
Provide a short and direct response. 1.39. What is the ratio of the Aid flow from DAC donars (current US$) in Europe(developing only) in 1994 to that in 2000?
Offer a terse response. 0.79. What is the ratio of the Aid flow from DAC donars (current US$) in Hungary in 1994 to that in 2000?
Make the answer very short. 0.78. What is the ratio of the Aid flow from DAC donars (current US$) in Papua New Guinea in 1994 to that in 2000?
Provide a succinct answer. 1.09. What is the ratio of the Aid flow from DAC donars (current US$) of Europe(developing only) in 1995 to that in 1996?
Offer a very short reply. 0.98. What is the ratio of the Aid flow from DAC donars (current US$) in Papua New Guinea in 1995 to that in 1996?
Give a very brief answer. 0.94. What is the ratio of the Aid flow from DAC donars (current US$) of Europe(developing only) in 1995 to that in 1997?
Offer a terse response. 1.13. What is the ratio of the Aid flow from DAC donars (current US$) in Papua New Guinea in 1995 to that in 1997?
Provide a short and direct response. 1.04. What is the ratio of the Aid flow from DAC donars (current US$) in Europe(developing only) in 1995 to that in 1998?
Make the answer very short. 0.91. What is the ratio of the Aid flow from DAC donars (current US$) in Papua New Guinea in 1995 to that in 1998?
Give a very brief answer. 0.98. What is the ratio of the Aid flow from DAC donars (current US$) in Europe(developing only) in 1995 to that in 1999?
Keep it short and to the point. 0.72. What is the ratio of the Aid flow from DAC donars (current US$) in Papua New Guinea in 1995 to that in 1999?
Your answer should be very brief. 1.65. What is the ratio of the Aid flow from DAC donars (current US$) in Europe(developing only) in 1995 to that in 2000?
Provide a short and direct response. 0.74. What is the ratio of the Aid flow from DAC donars (current US$) of Papua New Guinea in 1995 to that in 2000?
Your answer should be compact. 1.29. What is the ratio of the Aid flow from DAC donars (current US$) of Europe(developing only) in 1996 to that in 1997?
Provide a succinct answer. 1.15. What is the ratio of the Aid flow from DAC donars (current US$) of Hungary in 1996 to that in 1997?
Keep it short and to the point. 1.15. What is the ratio of the Aid flow from DAC donars (current US$) of Papua New Guinea in 1996 to that in 1997?
Offer a very short reply. 1.11. What is the ratio of the Aid flow from DAC donars (current US$) of Europe(developing only) in 1996 to that in 1998?
Ensure brevity in your answer.  0.93. What is the ratio of the Aid flow from DAC donars (current US$) in Hungary in 1996 to that in 1998?
Provide a succinct answer. 0.85. What is the ratio of the Aid flow from DAC donars (current US$) in Papua New Guinea in 1996 to that in 1998?
Ensure brevity in your answer.  1.04. What is the ratio of the Aid flow from DAC donars (current US$) in Europe(developing only) in 1996 to that in 1999?
Provide a succinct answer. 0.74. What is the ratio of the Aid flow from DAC donars (current US$) of Hungary in 1996 to that in 1999?
Keep it short and to the point. 0.81. What is the ratio of the Aid flow from DAC donars (current US$) of Papua New Guinea in 1996 to that in 1999?
Offer a terse response. 1.75. What is the ratio of the Aid flow from DAC donars (current US$) in Europe(developing only) in 1996 to that in 2000?
Keep it short and to the point. 0.76. What is the ratio of the Aid flow from DAC donars (current US$) in Hungary in 1996 to that in 2000?
Provide a short and direct response. 0.79. What is the ratio of the Aid flow from DAC donars (current US$) of Papua New Guinea in 1996 to that in 2000?
Provide a succinct answer. 1.37. What is the ratio of the Aid flow from DAC donars (current US$) in Europe(developing only) in 1997 to that in 1998?
Make the answer very short. 0.81. What is the ratio of the Aid flow from DAC donars (current US$) in Hungary in 1997 to that in 1998?
Ensure brevity in your answer.  0.74. What is the ratio of the Aid flow from DAC donars (current US$) of Papua New Guinea in 1997 to that in 1998?
Ensure brevity in your answer.  0.94. What is the ratio of the Aid flow from DAC donars (current US$) of Europe(developing only) in 1997 to that in 1999?
Your answer should be compact. 0.64. What is the ratio of the Aid flow from DAC donars (current US$) of Hungary in 1997 to that in 1999?
Provide a short and direct response. 0.7. What is the ratio of the Aid flow from DAC donars (current US$) of Papua New Guinea in 1997 to that in 1999?
Provide a short and direct response. 1.58. What is the ratio of the Aid flow from DAC donars (current US$) in Europe(developing only) in 1997 to that in 2000?
Ensure brevity in your answer.  0.66. What is the ratio of the Aid flow from DAC donars (current US$) of Hungary in 1997 to that in 2000?
Your answer should be compact. 0.69. What is the ratio of the Aid flow from DAC donars (current US$) of Papua New Guinea in 1997 to that in 2000?
Your answer should be very brief. 1.24. What is the ratio of the Aid flow from DAC donars (current US$) of Europe(developing only) in 1998 to that in 1999?
Offer a terse response. 0.79. What is the ratio of the Aid flow from DAC donars (current US$) in Hungary in 1998 to that in 1999?
Provide a succinct answer. 0.95. What is the ratio of the Aid flow from DAC donars (current US$) of Papua New Guinea in 1998 to that in 1999?
Offer a terse response. 1.68. What is the ratio of the Aid flow from DAC donars (current US$) of Europe(developing only) in 1998 to that in 2000?
Your response must be concise. 0.81. What is the ratio of the Aid flow from DAC donars (current US$) in Hungary in 1998 to that in 2000?
Provide a succinct answer. 0.94. What is the ratio of the Aid flow from DAC donars (current US$) of Papua New Guinea in 1998 to that in 2000?
Keep it short and to the point. 1.32. What is the ratio of the Aid flow from DAC donars (current US$) of Europe(developing only) in 1999 to that in 2000?
Make the answer very short. 1.03. What is the ratio of the Aid flow from DAC donars (current US$) in Hungary in 1999 to that in 2000?
Your answer should be compact. 0.98. What is the ratio of the Aid flow from DAC donars (current US$) in Papua New Guinea in 1999 to that in 2000?
Make the answer very short. 0.78. What is the difference between the highest and the second highest Aid flow from DAC donars (current US$) in Europe(developing only)?
Your answer should be compact. 1.62e+08. What is the difference between the highest and the second highest Aid flow from DAC donars (current US$) in Hungary?
Keep it short and to the point. 3.76e+06. What is the difference between the highest and the second highest Aid flow from DAC donars (current US$) of Papua New Guinea?
Your answer should be compact. 1.54e+07. What is the difference between the highest and the lowest Aid flow from DAC donars (current US$) in Europe(developing only)?
Keep it short and to the point. 2.23e+09. What is the difference between the highest and the lowest Aid flow from DAC donars (current US$) in Hungary?
Keep it short and to the point. 2.49e+08. What is the difference between the highest and the lowest Aid flow from DAC donars (current US$) in Papua New Guinea?
Your response must be concise. 1.59e+08. 